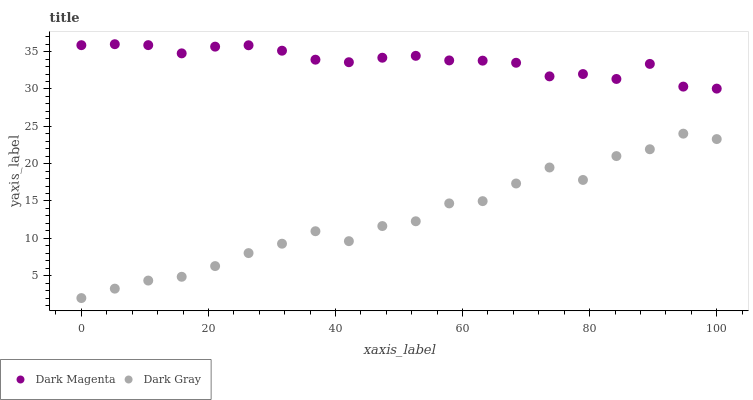Does Dark Gray have the minimum area under the curve?
Answer yes or no. Yes. Does Dark Magenta have the maximum area under the curve?
Answer yes or no. Yes. Does Dark Magenta have the minimum area under the curve?
Answer yes or no. No. Is Dark Magenta the smoothest?
Answer yes or no. Yes. Is Dark Gray the roughest?
Answer yes or no. Yes. Is Dark Magenta the roughest?
Answer yes or no. No. Does Dark Gray have the lowest value?
Answer yes or no. Yes. Does Dark Magenta have the lowest value?
Answer yes or no. No. Does Dark Magenta have the highest value?
Answer yes or no. Yes. Is Dark Gray less than Dark Magenta?
Answer yes or no. Yes. Is Dark Magenta greater than Dark Gray?
Answer yes or no. Yes. Does Dark Gray intersect Dark Magenta?
Answer yes or no. No. 